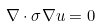<formula> <loc_0><loc_0><loc_500><loc_500>\nabla \cdot \sigma \nabla u = 0</formula> 